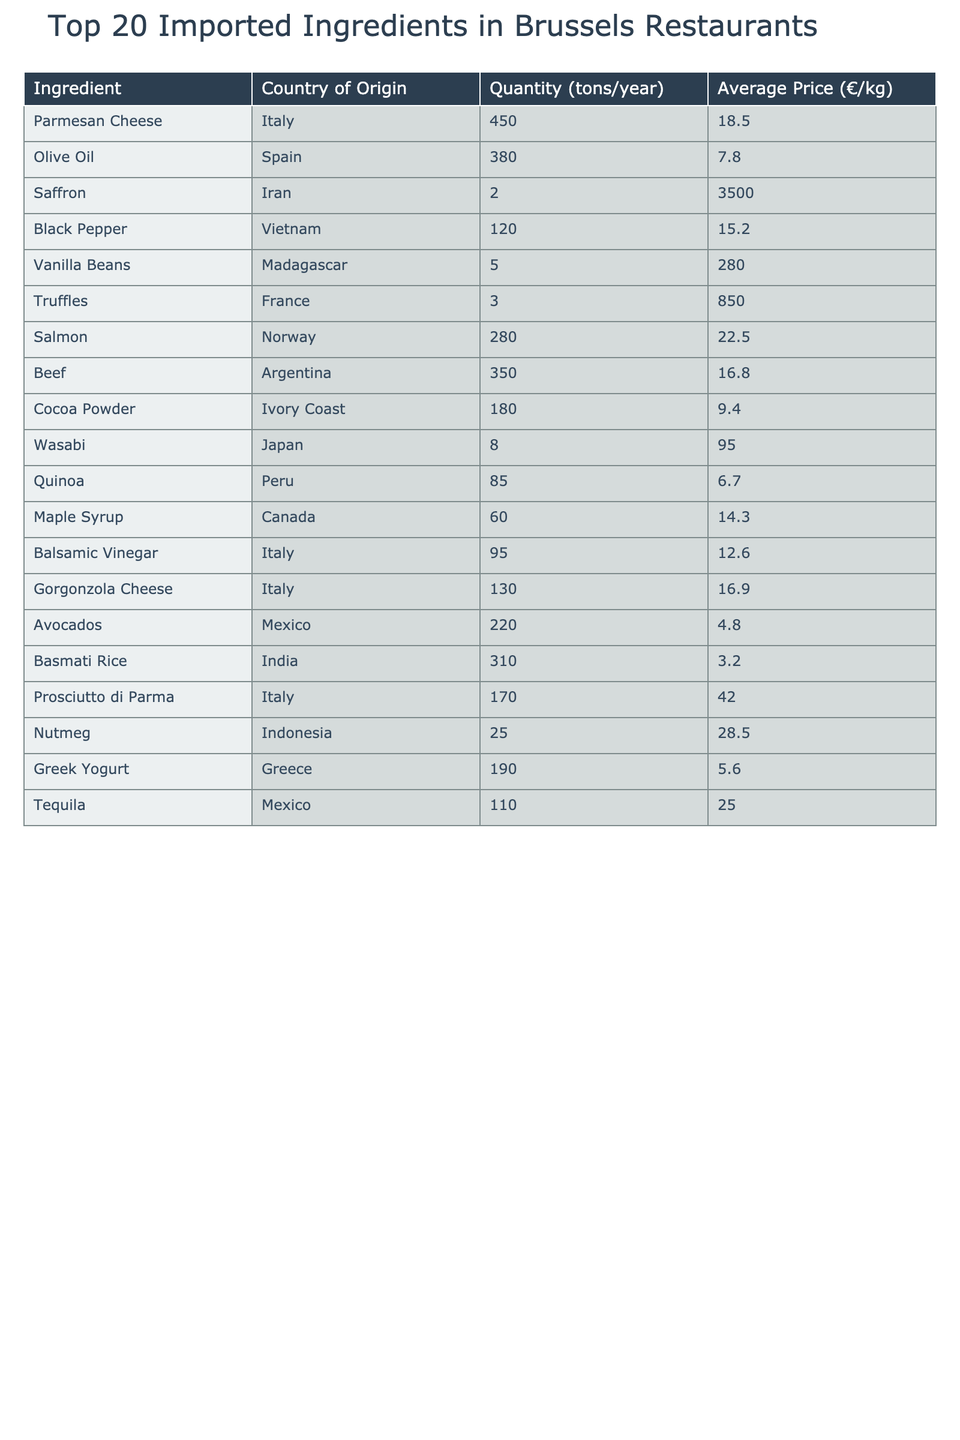What is the total quantity of ingredients imported from Italy? To find the total quantity from Italy, we sum the quantities of all Italian ingredients: Parmesan Cheese (450 tons), Balsamic Vinegar (95 tons), Gorgonzola Cheese (130 tons), and Prosciutto di Parma (170 tons). Adding these gives 450 + 95 + 130 + 170 = 845 tons.
Answer: 845 tons Which ingredient has the highest average price per kilogram? The ingredient with the highest average price is Saffron, priced at €3500.00 per kilogram.
Answer: Saffron What is the combined quantity of all seafood ingredients listed? The only seafood ingredient is Salmon, which has a quantity of 280 tons. Since there is no other seafood listed, the combined quantity is directly the quantity of Salmon itself.
Answer: 280 tons Is the quantity of Avocados greater than that of Quinoa? The quantity of Avocados is 220 tons, while Quinoa has 85 tons. Since 220 is greater than 85, the statement is true.
Answer: Yes What is the average price of all ingredients imported from Mexico? The ingredients from Mexico are Avocados (4.80 €/kg) and Tequila (25.00 €/kg). To find the average price, we sum these prices: 4.80 + 25.00 = 29.80, then divide by 2, giving 29.80 / 2 = 14.90 €/kg.
Answer: 14.90 €/kg Which country's ingredients have the highest overall quantity? To find the country with the highest overall quantity, we compare total quantities from each country: Italy (845 tons), Spain (380 tons), Iran (2 tons), Vietnam (120 tons), Norway (280 tons), etc. Italy has the highest quantity at 845 tons.
Answer: Italy How much more quantity is imported from Argentina than from Greece? The quantity imported from Argentina is 350 tons, while from Greece, it is 190 tons. The difference is 350 - 190 = 160 tons, indicating Argentina imports 160 tons more.
Answer: 160 tons Does the total of Brazilian ingredients exceed that of Ivory Coast? There are no Brazilian ingredients listed in the table, so the total for Brazil is 0 tons. Ivory Coast has 180 tons of Cocoa Powder. Since 0 is less than 180, the statement is false.
Answer: No What is the total quantity of spices (like Pepper and Nutmeg) imported? The spices listed are Black Pepper (120 tons) and Nutmeg (25 tons). Adding these gives us a total of 120 + 25 = 145 tons.
Answer: 145 tons What percentage of the total quantities imported comes from Japan? The quantity from Japan (Wasabi) is 8 tons. First, we calculate the total of all quantities imported: 450 + 380 + 2 + 120 + 5 + 3 + 280 + 350 + 180 + 8 + 85 + 60 + 95 + 130 + 220 + 310 + 170 + 25 + 190 + 110 = 2273 tons. The percentage for Japan is (8 / 2273) * 100 = 0.35%.
Answer: 0.35% 